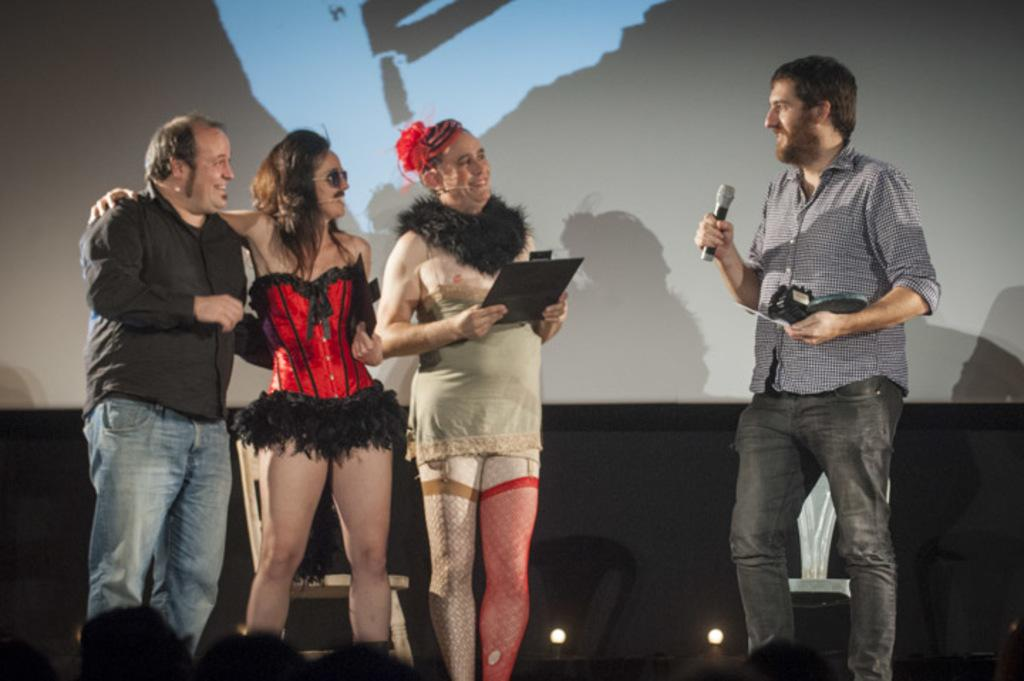How many people are standing in the front of the image? There are four people standing in the front of the image. What can be seen in the background of the image? There is a wall in the background of the image. What is the man on the right side of the image doing? The man on the right side of the image is talking on a microphone. How many jellyfish are swimming in the image? There are no jellyfish present in the image. What is the income of the people in the image? The income of the people in the image cannot be determined from the image itself. 